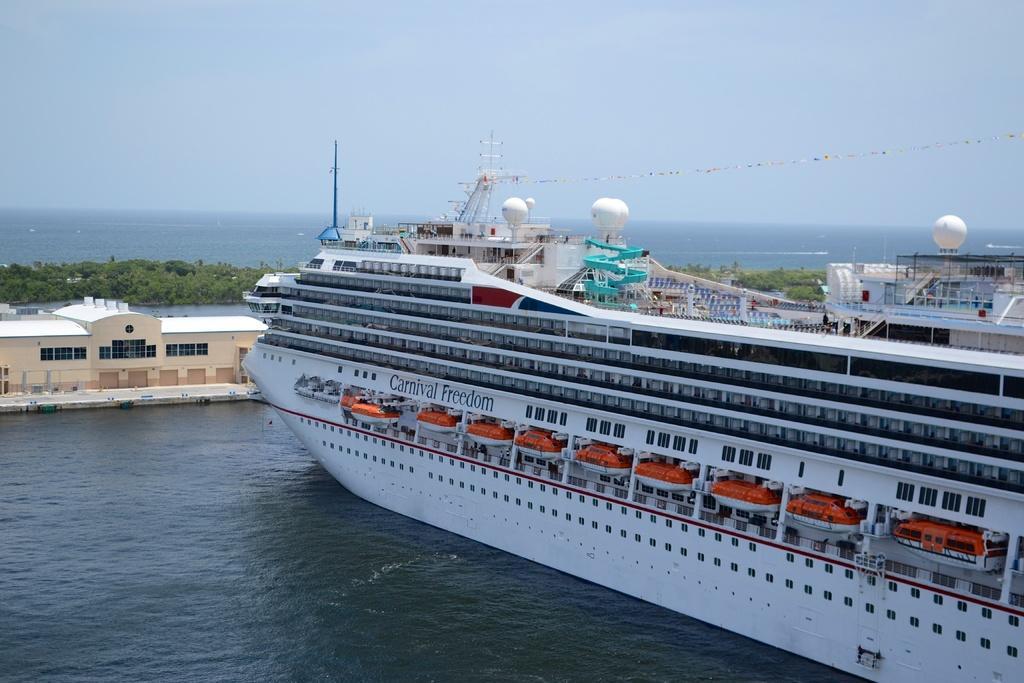Describe this image in one or two sentences. In this image, we can see ships on the water and in the background, there are trees and we can see a rope and at the top, there is sky. 